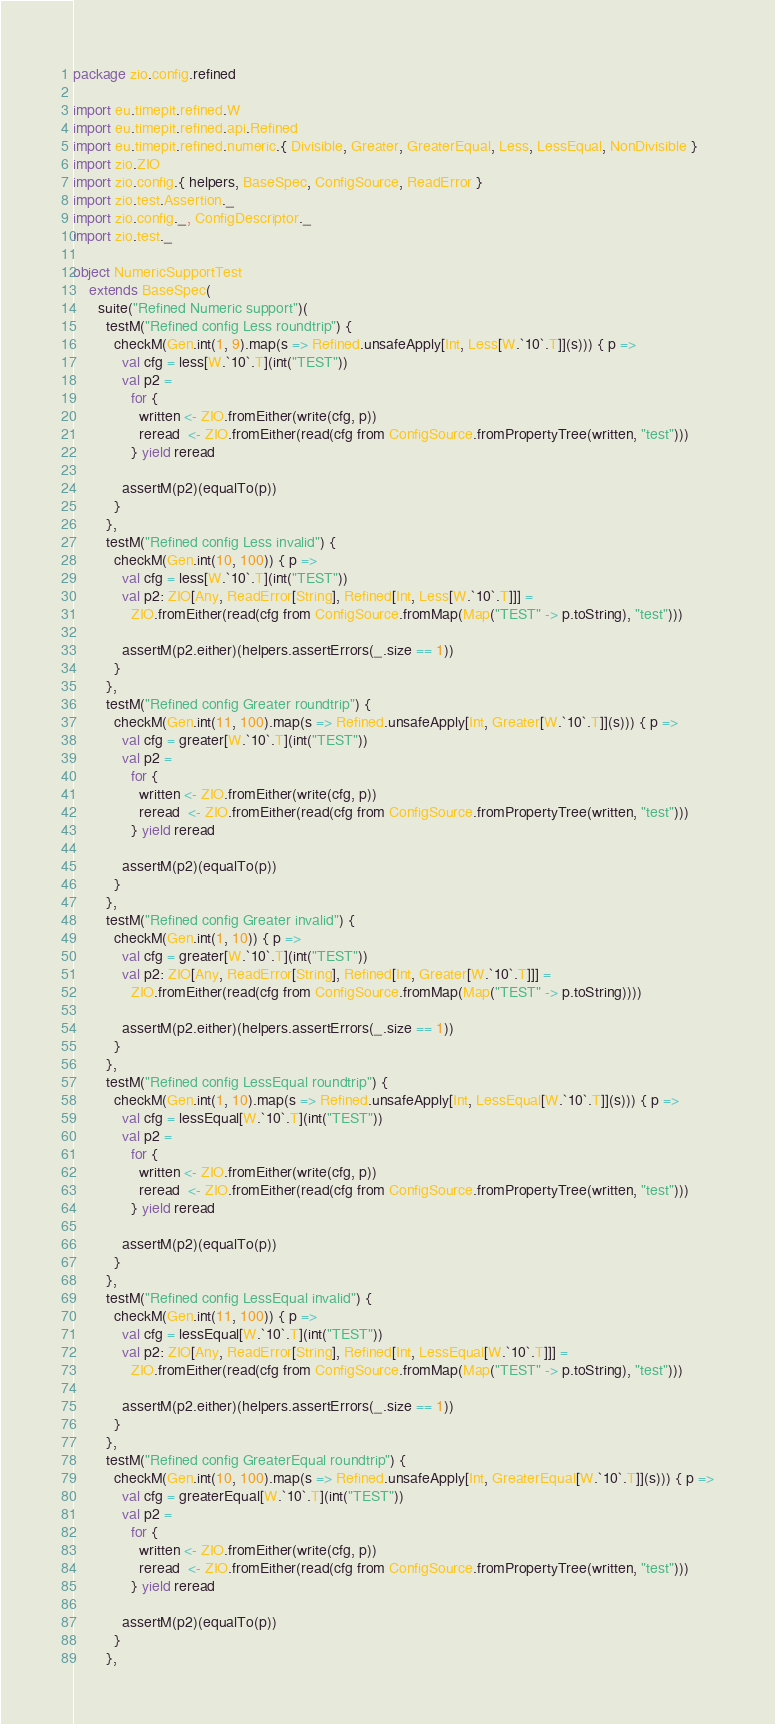Convert code to text. <code><loc_0><loc_0><loc_500><loc_500><_Scala_>package zio.config.refined

import eu.timepit.refined.W
import eu.timepit.refined.api.Refined
import eu.timepit.refined.numeric.{ Divisible, Greater, GreaterEqual, Less, LessEqual, NonDivisible }
import zio.ZIO
import zio.config.{ helpers, BaseSpec, ConfigSource, ReadError }
import zio.test.Assertion._
import zio.config._, ConfigDescriptor._
import zio.test._

object NumericSupportTest
    extends BaseSpec(
      suite("Refined Numeric support")(
        testM("Refined config Less roundtrip") {
          checkM(Gen.int(1, 9).map(s => Refined.unsafeApply[Int, Less[W.`10`.T]](s))) { p =>
            val cfg = less[W.`10`.T](int("TEST"))
            val p2 =
              for {
                written <- ZIO.fromEither(write(cfg, p))
                reread  <- ZIO.fromEither(read(cfg from ConfigSource.fromPropertyTree(written, "test")))
              } yield reread

            assertM(p2)(equalTo(p))
          }
        },
        testM("Refined config Less invalid") {
          checkM(Gen.int(10, 100)) { p =>
            val cfg = less[W.`10`.T](int("TEST"))
            val p2: ZIO[Any, ReadError[String], Refined[Int, Less[W.`10`.T]]] =
              ZIO.fromEither(read(cfg from ConfigSource.fromMap(Map("TEST" -> p.toString), "test")))

            assertM(p2.either)(helpers.assertErrors(_.size == 1))
          }
        },
        testM("Refined config Greater roundtrip") {
          checkM(Gen.int(11, 100).map(s => Refined.unsafeApply[Int, Greater[W.`10`.T]](s))) { p =>
            val cfg = greater[W.`10`.T](int("TEST"))
            val p2 =
              for {
                written <- ZIO.fromEither(write(cfg, p))
                reread  <- ZIO.fromEither(read(cfg from ConfigSource.fromPropertyTree(written, "test")))
              } yield reread

            assertM(p2)(equalTo(p))
          }
        },
        testM("Refined config Greater invalid") {
          checkM(Gen.int(1, 10)) { p =>
            val cfg = greater[W.`10`.T](int("TEST"))
            val p2: ZIO[Any, ReadError[String], Refined[Int, Greater[W.`10`.T]]] =
              ZIO.fromEither(read(cfg from ConfigSource.fromMap(Map("TEST" -> p.toString))))

            assertM(p2.either)(helpers.assertErrors(_.size == 1))
          }
        },
        testM("Refined config LessEqual roundtrip") {
          checkM(Gen.int(1, 10).map(s => Refined.unsafeApply[Int, LessEqual[W.`10`.T]](s))) { p =>
            val cfg = lessEqual[W.`10`.T](int("TEST"))
            val p2 =
              for {
                written <- ZIO.fromEither(write(cfg, p))
                reread  <- ZIO.fromEither(read(cfg from ConfigSource.fromPropertyTree(written, "test")))
              } yield reread

            assertM(p2)(equalTo(p))
          }
        },
        testM("Refined config LessEqual invalid") {
          checkM(Gen.int(11, 100)) { p =>
            val cfg = lessEqual[W.`10`.T](int("TEST"))
            val p2: ZIO[Any, ReadError[String], Refined[Int, LessEqual[W.`10`.T]]] =
              ZIO.fromEither(read(cfg from ConfigSource.fromMap(Map("TEST" -> p.toString), "test")))

            assertM(p2.either)(helpers.assertErrors(_.size == 1))
          }
        },
        testM("Refined config GreaterEqual roundtrip") {
          checkM(Gen.int(10, 100).map(s => Refined.unsafeApply[Int, GreaterEqual[W.`10`.T]](s))) { p =>
            val cfg = greaterEqual[W.`10`.T](int("TEST"))
            val p2 =
              for {
                written <- ZIO.fromEither(write(cfg, p))
                reread  <- ZIO.fromEither(read(cfg from ConfigSource.fromPropertyTree(written, "test")))
              } yield reread

            assertM(p2)(equalTo(p))
          }
        },</code> 